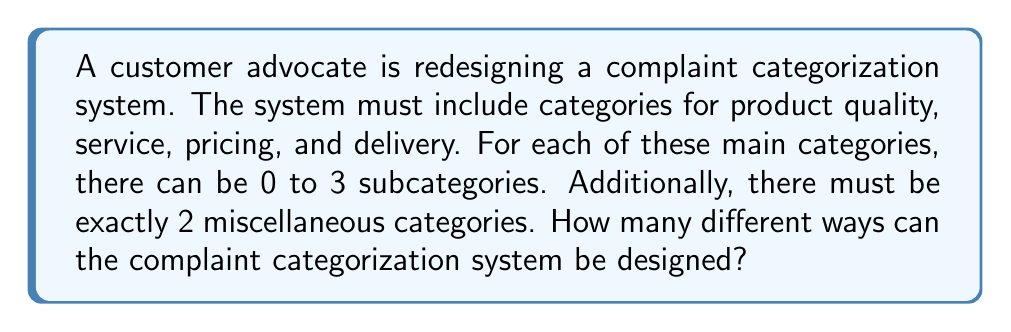Solve this math problem. Let's approach this step-by-step:

1) We have 4 main categories (product quality, service, pricing, and delivery), each of which can have 0 to 3 subcategories.

2) For each main category, we have 4 choices (0, 1, 2, or 3 subcategories). This can be represented as $4^4$ combinations for the main categories.

3) The miscellaneous categories are fixed at 2, so there's only one way to arrange those.

4) Using the multiplication principle, we multiply these together:

   $$\text{Total combinations} = 4^4 \cdot 1$$

5) Let's calculate:
   $$4^4 = 4 \cdot 4 \cdot 4 \cdot 4 = 256$$

6) Therefore, the total number of ways to design the system is 256.

This approach ensures that all legal requirements are met (inclusion of all necessary categories) while allowing flexibility in subcategories, which protects customer interests by enabling a detailed and adaptable complaint system.
Answer: 256 